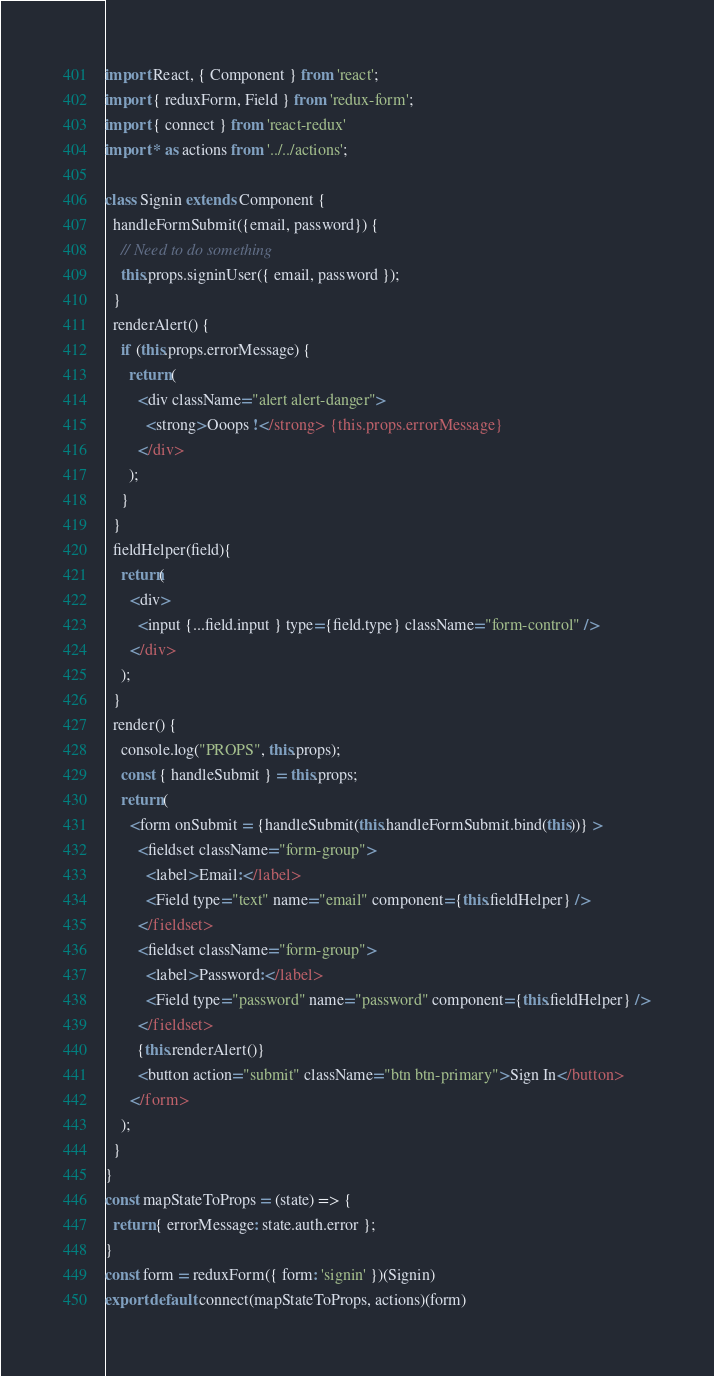<code> <loc_0><loc_0><loc_500><loc_500><_JavaScript_>import React, { Component } from 'react';
import { reduxForm, Field } from 'redux-form';
import { connect } from 'react-redux'
import * as actions from '../../actions';

class Signin extends Component {
  handleFormSubmit({email, password}) {
    // Need to do something
    this.props.signinUser({ email, password });
  }
  renderAlert() {
    if (this.props.errorMessage) {
      return (
        <div className="alert alert-danger">
          <strong>Ooops !</strong> {this.props.errorMessage}
        </div>
      );
    }
  }
  fieldHelper(field){
    return(
      <div>
        <input {...field.input } type={field.type} className="form-control" />
      </div>
    );
  }
  render() {
    console.log("PROPS", this.props);
    const { handleSubmit } = this.props;
    return (
      <form onSubmit = {handleSubmit(this.handleFormSubmit.bind(this))} >
        <fieldset className="form-group">
          <label>Email:</label>
          <Field type="text" name="email" component={this.fieldHelper} />
        </fieldset>
        <fieldset className="form-group">
          <label>Password:</label>
          <Field type="password" name="password" component={this.fieldHelper} />
        </fieldset>
        {this.renderAlert()}
        <button action="submit" className="btn btn-primary">Sign In</button>
      </form>
    );
  }
}
const mapStateToProps = (state) => {
  return { errorMessage: state.auth.error };
}
const form = reduxForm({ form: 'signin' })(Signin)
export default connect(mapStateToProps, actions)(form)
</code> 